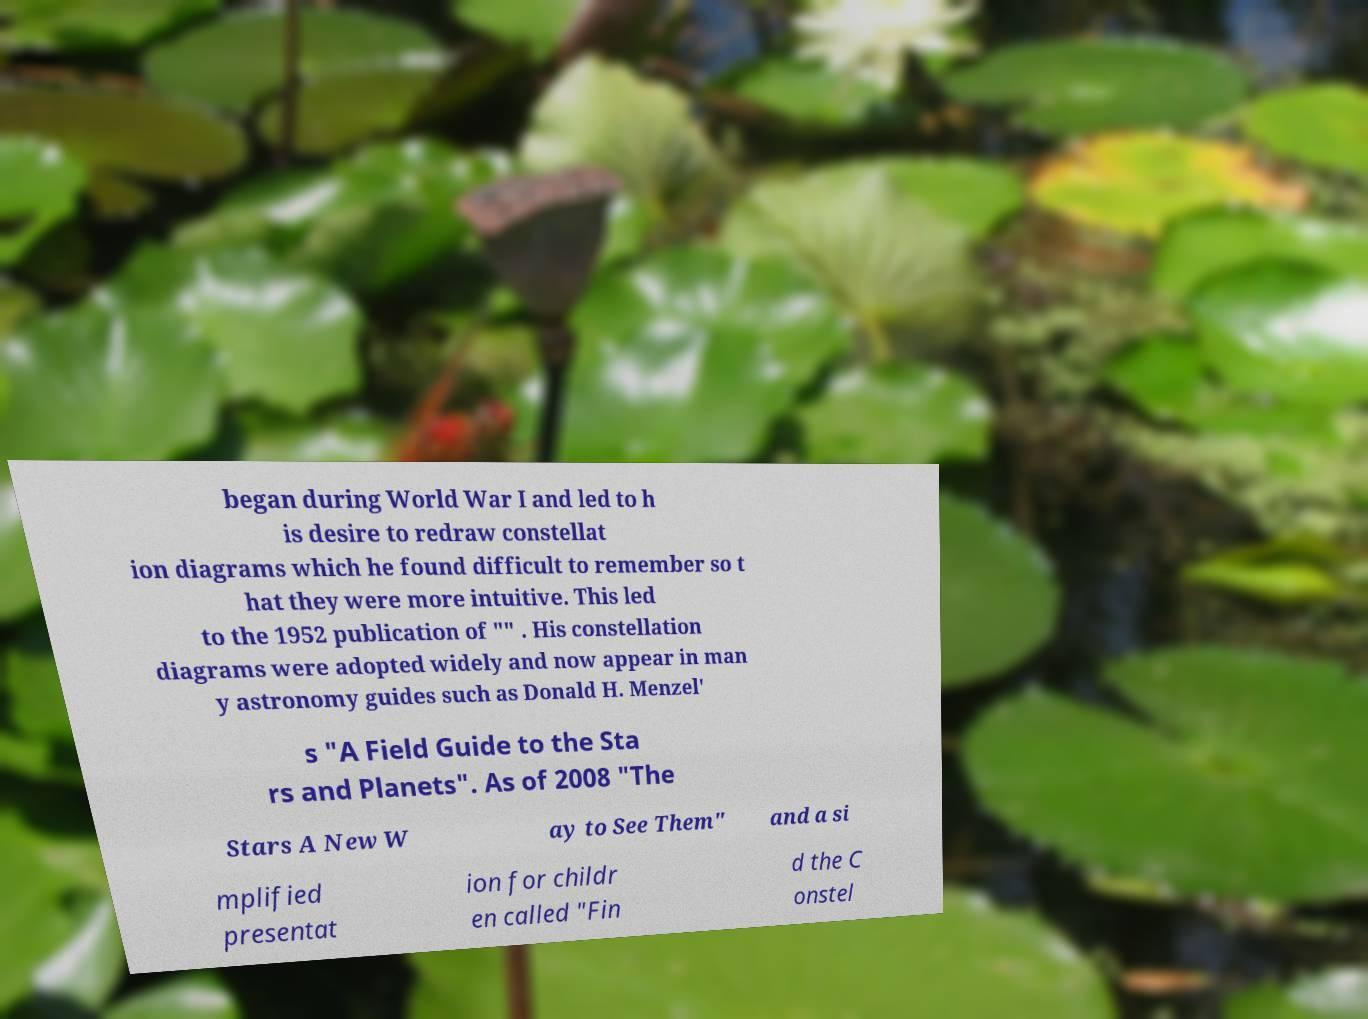Can you accurately transcribe the text from the provided image for me? began during World War I and led to h is desire to redraw constellat ion diagrams which he found difficult to remember so t hat they were more intuitive. This led to the 1952 publication of "" . His constellation diagrams were adopted widely and now appear in man y astronomy guides such as Donald H. Menzel' s "A Field Guide to the Sta rs and Planets". As of 2008 "The Stars A New W ay to See Them" and a si mplified presentat ion for childr en called "Fin d the C onstel 